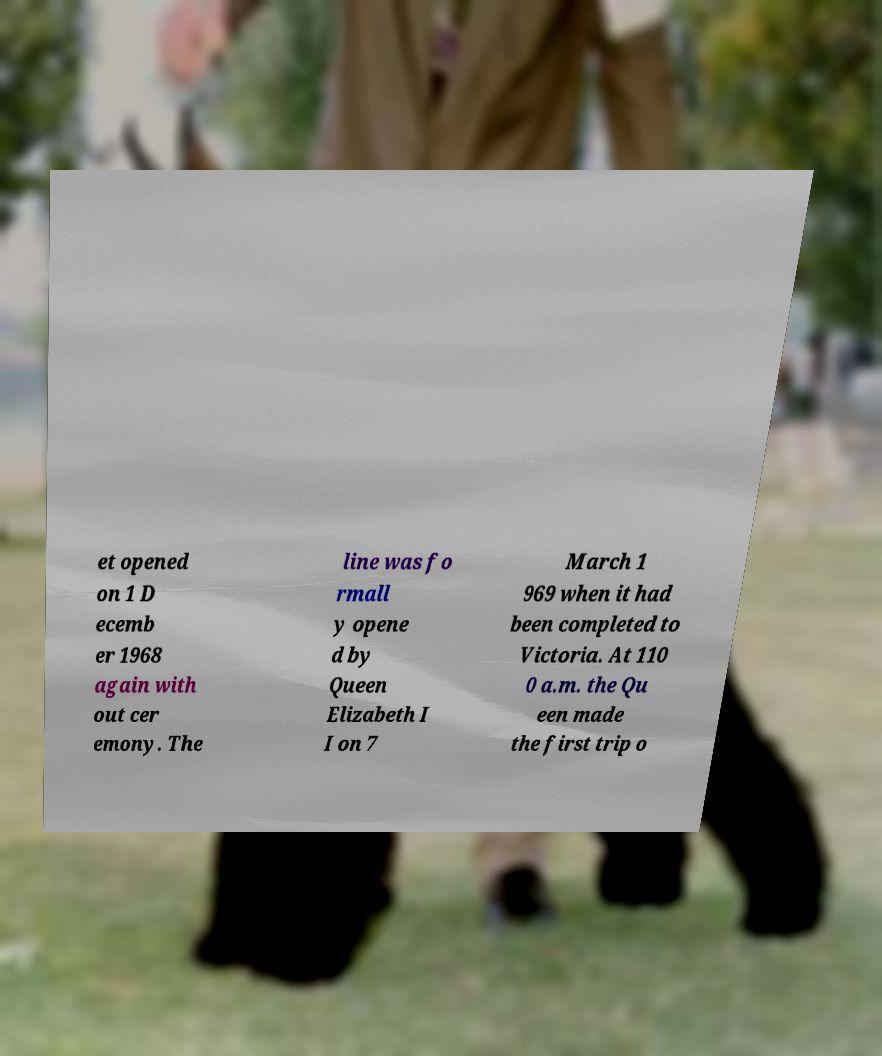Please read and relay the text visible in this image. What does it say? et opened on 1 D ecemb er 1968 again with out cer emony. The line was fo rmall y opene d by Queen Elizabeth I I on 7 March 1 969 when it had been completed to Victoria. At 110 0 a.m. the Qu een made the first trip o 